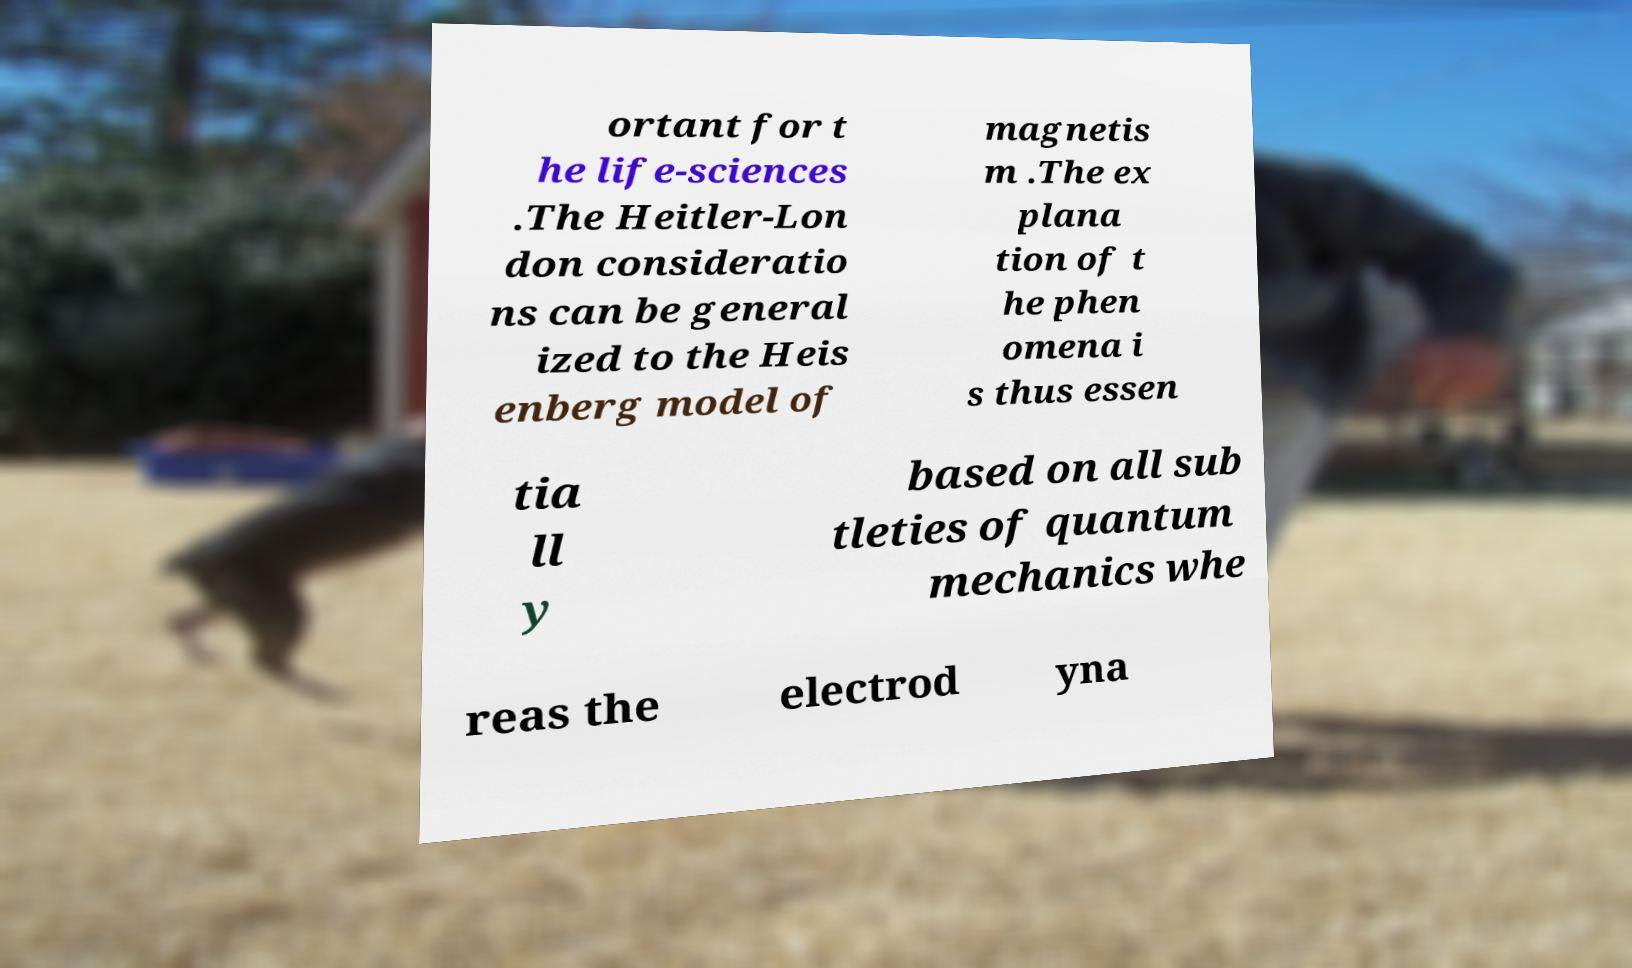Could you assist in decoding the text presented in this image and type it out clearly? ortant for t he life-sciences .The Heitler-Lon don consideratio ns can be general ized to the Heis enberg model of magnetis m .The ex plana tion of t he phen omena i s thus essen tia ll y based on all sub tleties of quantum mechanics whe reas the electrod yna 